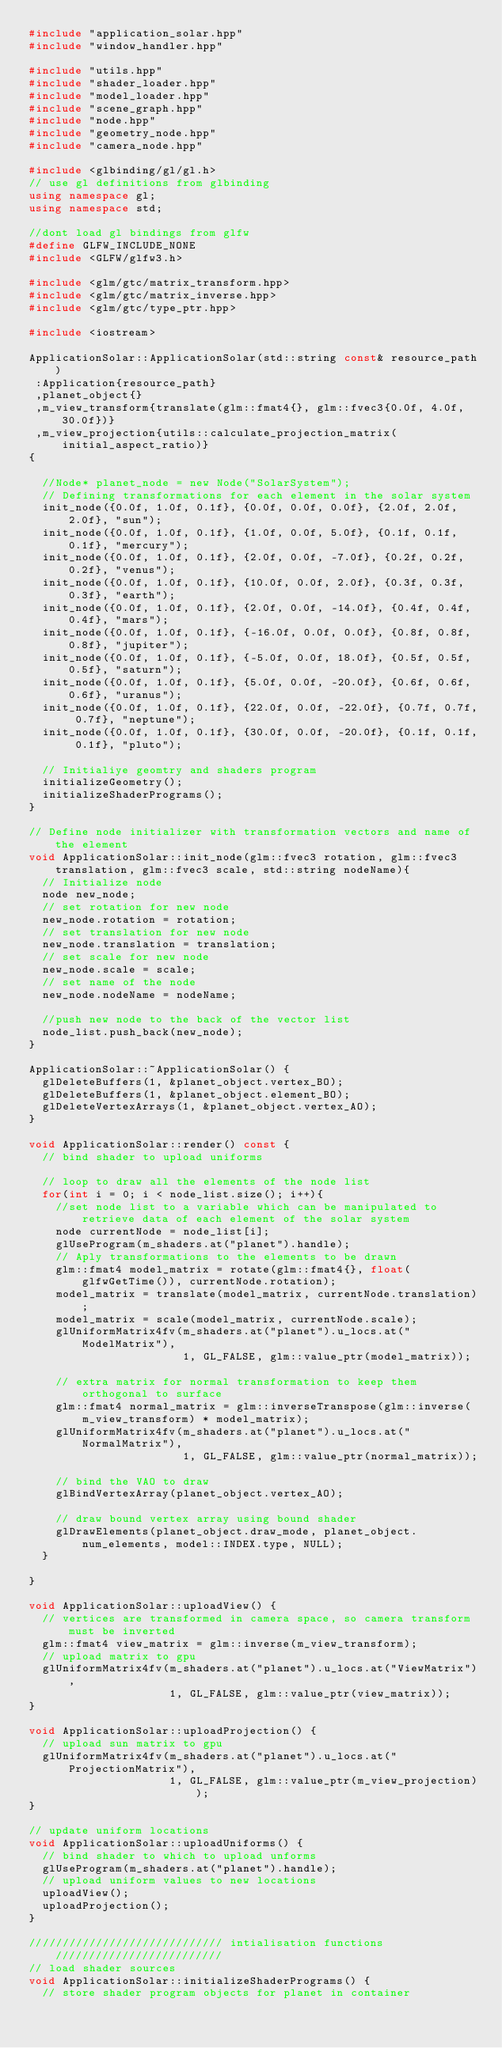<code> <loc_0><loc_0><loc_500><loc_500><_C++_>#include "application_solar.hpp"
#include "window_handler.hpp"

#include "utils.hpp"
#include "shader_loader.hpp"
#include "model_loader.hpp"
#include "scene_graph.hpp"
#include "node.hpp"
#include "geometry_node.hpp"
#include "camera_node.hpp"

#include <glbinding/gl/gl.h>
// use gl definitions from glbinding 
using namespace gl;
using namespace std;

//dont load gl bindings from glfw
#define GLFW_INCLUDE_NONE
#include <GLFW/glfw3.h>

#include <glm/gtc/matrix_transform.hpp>
#include <glm/gtc/matrix_inverse.hpp>
#include <glm/gtc/type_ptr.hpp>

#include <iostream>

ApplicationSolar::ApplicationSolar(std::string const& resource_path)
 :Application{resource_path}
 ,planet_object{}
 ,m_view_transform{translate(glm::fmat4{}, glm::fvec3{0.0f, 4.0f, 30.0f})}
 ,m_view_projection{utils::calculate_projection_matrix(initial_aspect_ratio)}
{

  //Node* planet_node = new Node("SolarSystem");
  // Defining transformations for each element in the solar system
  init_node({0.0f, 1.0f, 0.1f}, {0.0f, 0.0f, 0.0f}, {2.0f, 2.0f, 2.0f}, "sun");
  init_node({0.0f, 1.0f, 0.1f}, {1.0f, 0.0f, 5.0f}, {0.1f, 0.1f, 0.1f}, "mercury");
  init_node({0.0f, 1.0f, 0.1f}, {2.0f, 0.0f, -7.0f}, {0.2f, 0.2f, 0.2f}, "venus");
  init_node({0.0f, 1.0f, 0.1f}, {10.0f, 0.0f, 2.0f}, {0.3f, 0.3f, 0.3f}, "earth");
  init_node({0.0f, 1.0f, 0.1f}, {2.0f, 0.0f, -14.0f}, {0.4f, 0.4f, 0.4f}, "mars");
  init_node({0.0f, 1.0f, 0.1f}, {-16.0f, 0.0f, 0.0f}, {0.8f, 0.8f, 0.8f}, "jupiter");
  init_node({0.0f, 1.0f, 0.1f}, {-5.0f, 0.0f, 18.0f}, {0.5f, 0.5f, 0.5f}, "saturn");
  init_node({0.0f, 1.0f, 0.1f}, {5.0f, 0.0f, -20.0f}, {0.6f, 0.6f, 0.6f}, "uranus");
  init_node({0.0f, 1.0f, 0.1f}, {22.0f, 0.0f, -22.0f}, {0.7f, 0.7f, 0.7f}, "neptune");
  init_node({0.0f, 1.0f, 0.1f}, {30.0f, 0.0f, -20.0f}, {0.1f, 0.1f, 0.1f}, "pluto");

  // Initialiye geomtry and shaders program
  initializeGeometry();
  initializeShaderPrograms();
}

// Define node initializer with transformation vectors and name of the element
void ApplicationSolar::init_node(glm::fvec3 rotation, glm::fvec3 translation, glm::fvec3 scale, std::string nodeName){
  // Initialize node
  node new_node;
  // set rotation for new node
  new_node.rotation = rotation;
  // set translation for new node
  new_node.translation = translation;
  // set scale for new node
  new_node.scale = scale;
  // set name of the node
  new_node.nodeName = nodeName;

  //push new node to the back of the vector list
  node_list.push_back(new_node);
}

ApplicationSolar::~ApplicationSolar() {
  glDeleteBuffers(1, &planet_object.vertex_BO);
  glDeleteBuffers(1, &planet_object.element_BO);
  glDeleteVertexArrays(1, &planet_object.vertex_AO);
}

void ApplicationSolar::render() const {
  // bind shader to upload uniforms

  // loop to draw all the elements of the node list
  for(int i = 0; i < node_list.size(); i++){
    //set node list to a variable which can be manipulated to retrieve data of each element of the solar system
    node currentNode = node_list[i];
    glUseProgram(m_shaders.at("planet").handle);
    // Aply transformations to the elements to be drawn
    glm::fmat4 model_matrix = rotate(glm::fmat4{}, float(glfwGetTime()), currentNode.rotation);
    model_matrix = translate(model_matrix, currentNode.translation);
    model_matrix = scale(model_matrix, currentNode.scale);
    glUniformMatrix4fv(m_shaders.at("planet").u_locs.at("ModelMatrix"),
                       1, GL_FALSE, glm::value_ptr(model_matrix));

    // extra matrix for normal transformation to keep them orthogonal to surface
    glm::fmat4 normal_matrix = glm::inverseTranspose(glm::inverse(m_view_transform) * model_matrix);
    glUniformMatrix4fv(m_shaders.at("planet").u_locs.at("NormalMatrix"),
                       1, GL_FALSE, glm::value_ptr(normal_matrix));

    // bind the VAO to draw
    glBindVertexArray(planet_object.vertex_AO);

    // draw bound vertex array using bound shader
    glDrawElements(planet_object.draw_mode, planet_object.num_elements, model::INDEX.type, NULL);
  }

}

void ApplicationSolar::uploadView() {
  // vertices are transformed in camera space, so camera transform must be inverted
  glm::fmat4 view_matrix = glm::inverse(m_view_transform);
  // upload matrix to gpu
  glUniformMatrix4fv(m_shaders.at("planet").u_locs.at("ViewMatrix"),
                     1, GL_FALSE, glm::value_ptr(view_matrix));
}

void ApplicationSolar::uploadProjection() {
  // upload sun matrix to gpu
  glUniformMatrix4fv(m_shaders.at("planet").u_locs.at("ProjectionMatrix"),
                     1, GL_FALSE, glm::value_ptr(m_view_projection));
}

// update uniform locations
void ApplicationSolar::uploadUniforms() { 
  // bind shader to which to upload unforms
  glUseProgram(m_shaders.at("planet").handle);
  // upload uniform values to new locations
  uploadView();
  uploadProjection();
}

///////////////////////////// intialisation functions /////////////////////////
// load shader sources
void ApplicationSolar::initializeShaderPrograms() {
  // store shader program objects for planet in container</code> 